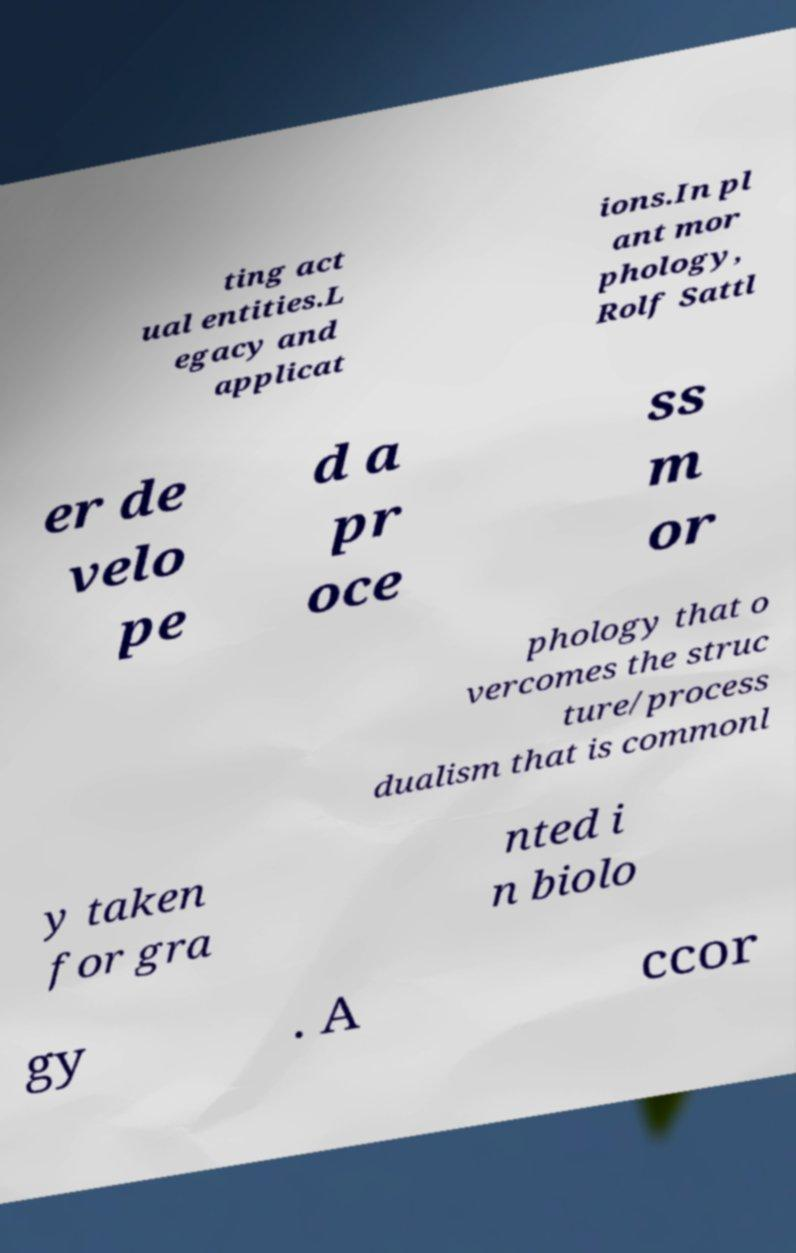What messages or text are displayed in this image? I need them in a readable, typed format. ting act ual entities.L egacy and applicat ions.In pl ant mor phology, Rolf Sattl er de velo pe d a pr oce ss m or phology that o vercomes the struc ture/process dualism that is commonl y taken for gra nted i n biolo gy . A ccor 